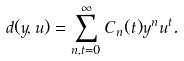Convert formula to latex. <formula><loc_0><loc_0><loc_500><loc_500>d ( y , u ) = \sum _ { n , t = 0 } ^ { \infty } C _ { n } ( t ) y ^ { n } u ^ { t } .</formula> 